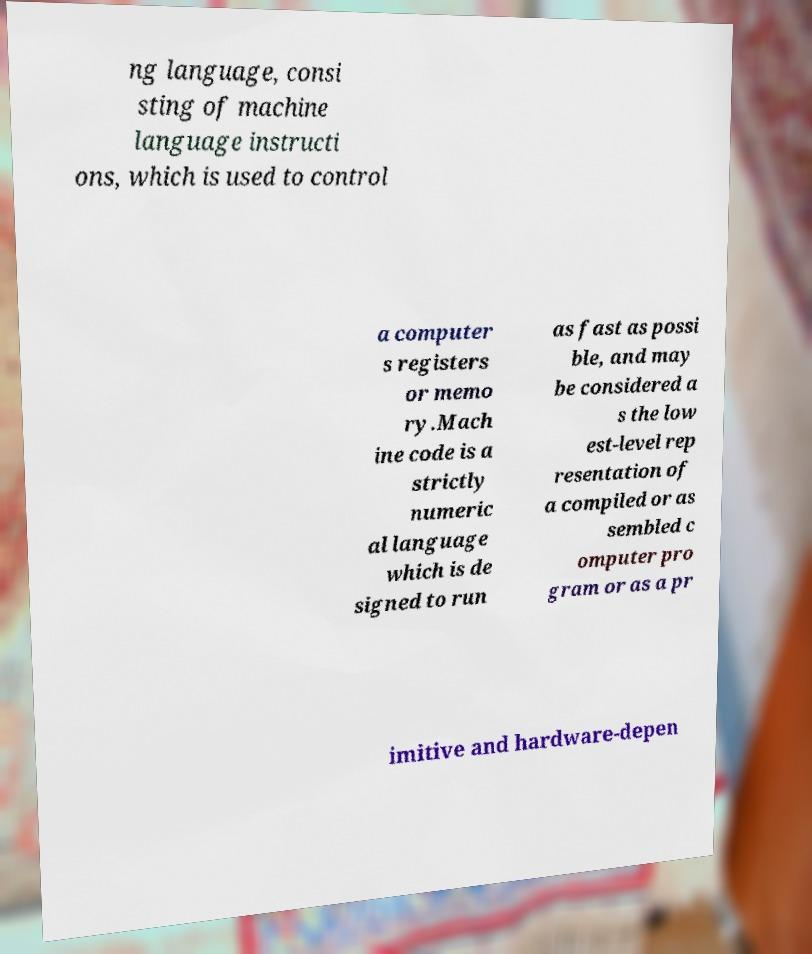Can you accurately transcribe the text from the provided image for me? ng language, consi sting of machine language instructi ons, which is used to control a computer s registers or memo ry.Mach ine code is a strictly numeric al language which is de signed to run as fast as possi ble, and may be considered a s the low est-level rep resentation of a compiled or as sembled c omputer pro gram or as a pr imitive and hardware-depen 